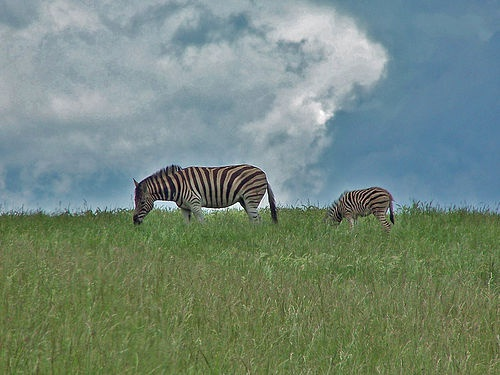Describe the objects in this image and their specific colors. I can see zebra in gray, black, and darkgray tones and zebra in gray, black, darkgray, and darkgreen tones in this image. 